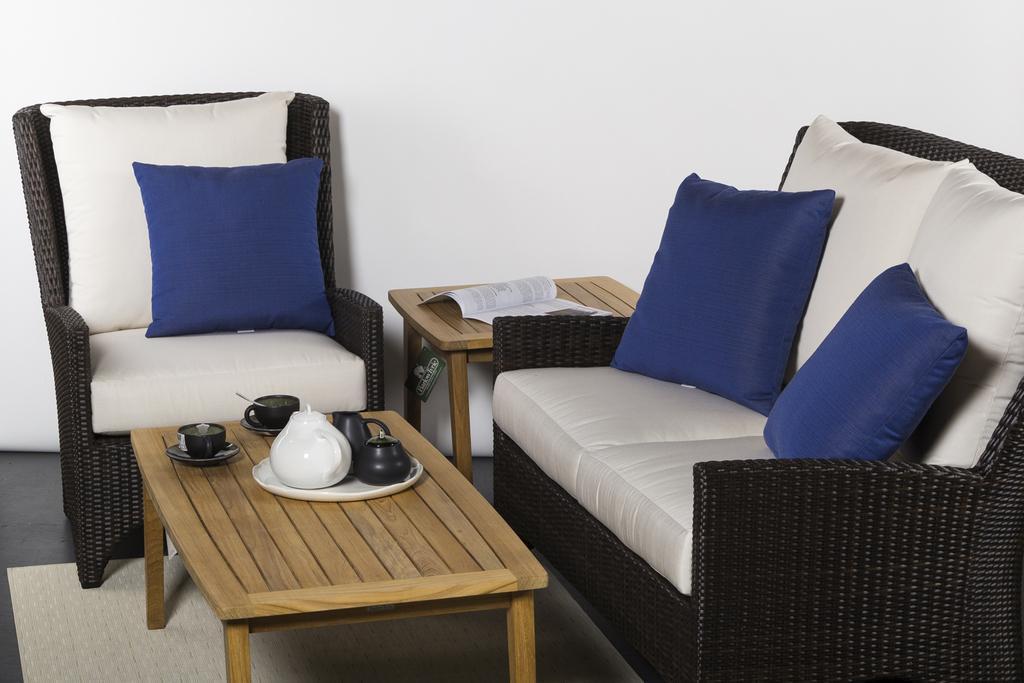How would you summarize this image in a sentence or two? In this image there is a sofa. The image is clicked inside the room. In front of sofa there is a teapoy on which cups and saucers are kept. There are three blue color pillows on the sofa. In the background there is a white color wall. At the bottom there is a floor mat. 